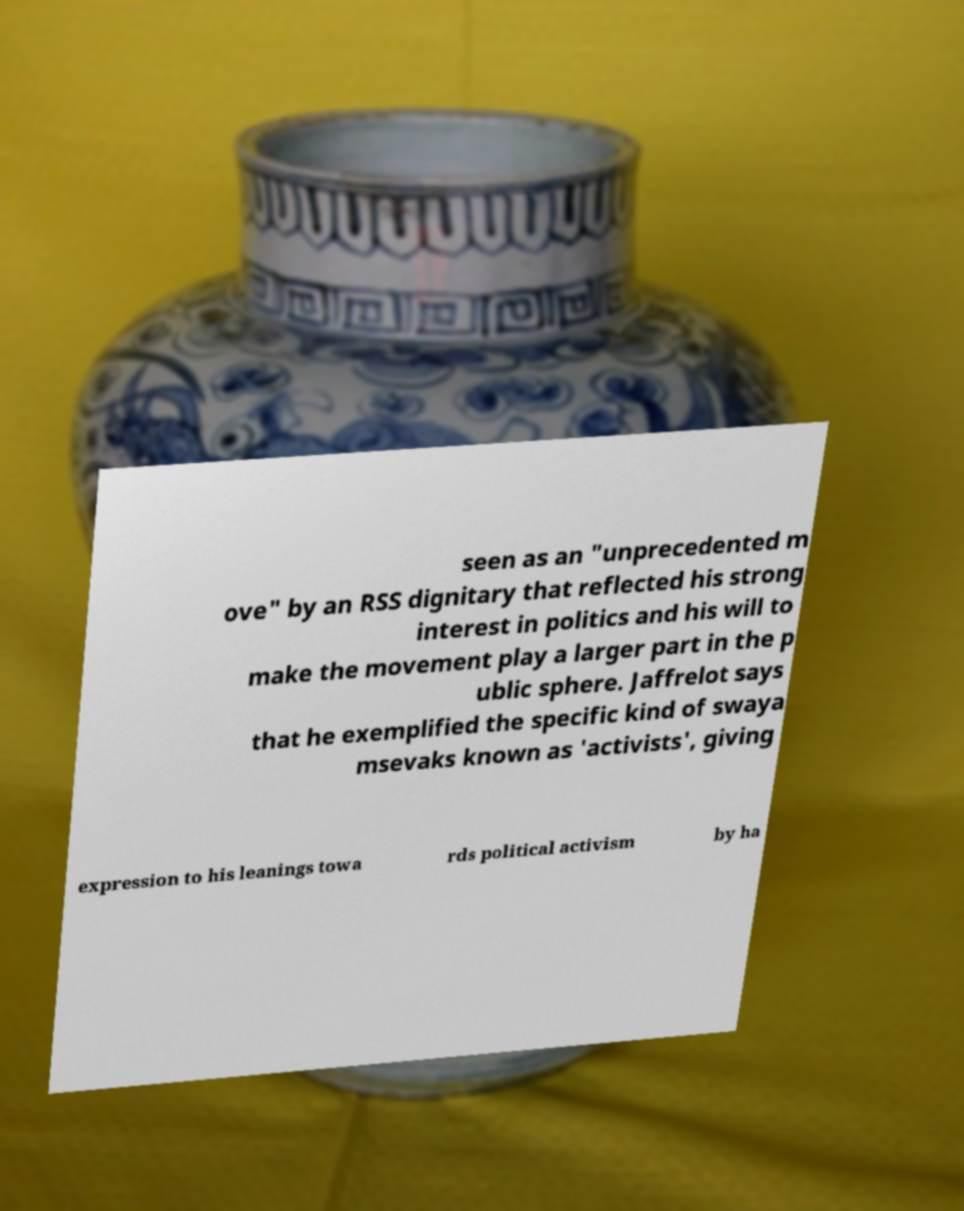Could you assist in decoding the text presented in this image and type it out clearly? seen as an "unprecedented m ove" by an RSS dignitary that reflected his strong interest in politics and his will to make the movement play a larger part in the p ublic sphere. Jaffrelot says that he exemplified the specific kind of swaya msevaks known as 'activists', giving expression to his leanings towa rds political activism by ha 